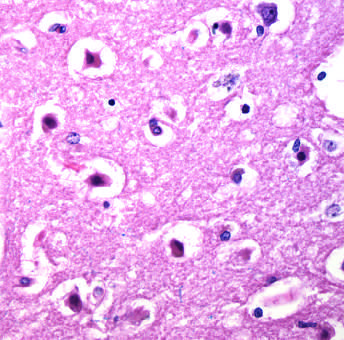what are shrunken and eosinophilic?
Answer the question using a single word or phrase. The cell bodies 